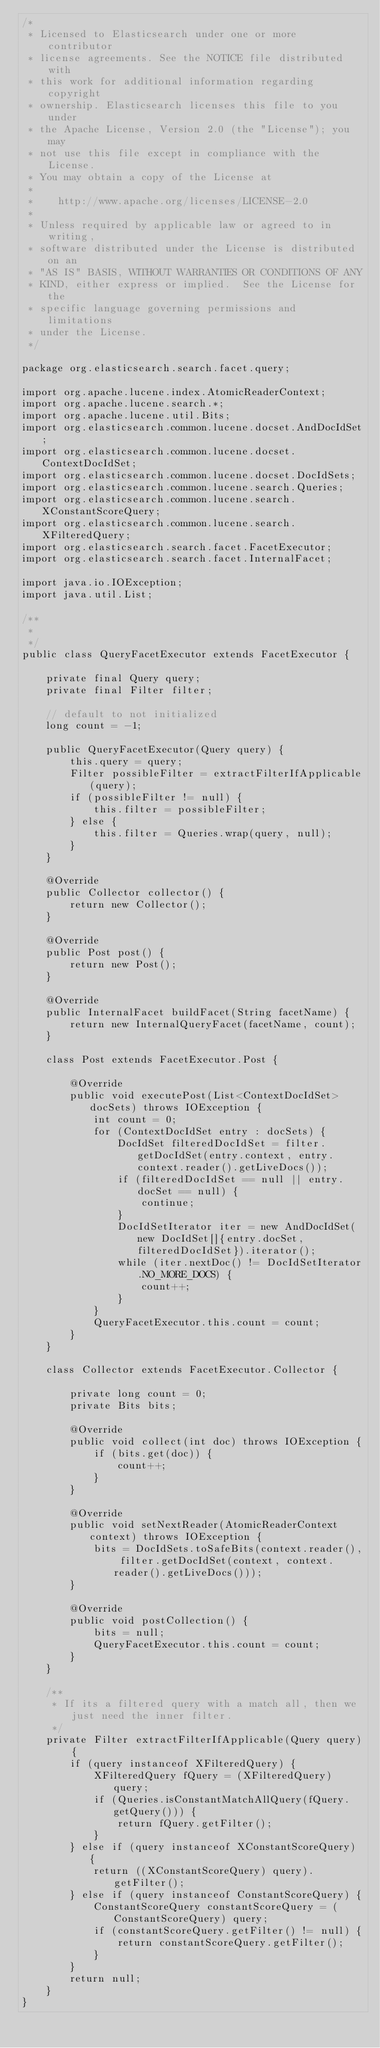Convert code to text. <code><loc_0><loc_0><loc_500><loc_500><_Java_>/*
 * Licensed to Elasticsearch under one or more contributor
 * license agreements. See the NOTICE file distributed with
 * this work for additional information regarding copyright
 * ownership. Elasticsearch licenses this file to you under
 * the Apache License, Version 2.0 (the "License"); you may
 * not use this file except in compliance with the License.
 * You may obtain a copy of the License at
 *
 *    http://www.apache.org/licenses/LICENSE-2.0
 *
 * Unless required by applicable law or agreed to in writing,
 * software distributed under the License is distributed on an
 * "AS IS" BASIS, WITHOUT WARRANTIES OR CONDITIONS OF ANY
 * KIND, either express or implied.  See the License for the
 * specific language governing permissions and limitations
 * under the License.
 */

package org.elasticsearch.search.facet.query;

import org.apache.lucene.index.AtomicReaderContext;
import org.apache.lucene.search.*;
import org.apache.lucene.util.Bits;
import org.elasticsearch.common.lucene.docset.AndDocIdSet;
import org.elasticsearch.common.lucene.docset.ContextDocIdSet;
import org.elasticsearch.common.lucene.docset.DocIdSets;
import org.elasticsearch.common.lucene.search.Queries;
import org.elasticsearch.common.lucene.search.XConstantScoreQuery;
import org.elasticsearch.common.lucene.search.XFilteredQuery;
import org.elasticsearch.search.facet.FacetExecutor;
import org.elasticsearch.search.facet.InternalFacet;

import java.io.IOException;
import java.util.List;

/**
 *
 */
public class QueryFacetExecutor extends FacetExecutor {

    private final Query query;
    private final Filter filter;

    // default to not initialized
    long count = -1;

    public QueryFacetExecutor(Query query) {
        this.query = query;
        Filter possibleFilter = extractFilterIfApplicable(query);
        if (possibleFilter != null) {
            this.filter = possibleFilter;
        } else {
            this.filter = Queries.wrap(query, null);
        }
    }

    @Override
    public Collector collector() {
        return new Collector();
    }

    @Override
    public Post post() {
        return new Post();
    }

    @Override
    public InternalFacet buildFacet(String facetName) {
        return new InternalQueryFacet(facetName, count);
    }

    class Post extends FacetExecutor.Post {

        @Override
        public void executePost(List<ContextDocIdSet> docSets) throws IOException {
            int count = 0;
            for (ContextDocIdSet entry : docSets) {
                DocIdSet filteredDocIdSet = filter.getDocIdSet(entry.context, entry.context.reader().getLiveDocs());
                if (filteredDocIdSet == null || entry.docSet == null) {
                    continue;
                }
                DocIdSetIterator iter = new AndDocIdSet(new DocIdSet[]{entry.docSet, filteredDocIdSet}).iterator();
                while (iter.nextDoc() != DocIdSetIterator.NO_MORE_DOCS) {
                    count++;
                }
            }
            QueryFacetExecutor.this.count = count;
        }
    }

    class Collector extends FacetExecutor.Collector {

        private long count = 0;
        private Bits bits;

        @Override
        public void collect(int doc) throws IOException {
            if (bits.get(doc)) {
                count++;
            }
        }

        @Override
        public void setNextReader(AtomicReaderContext context) throws IOException {
            bits = DocIdSets.toSafeBits(context.reader(), filter.getDocIdSet(context, context.reader().getLiveDocs()));
        }

        @Override
        public void postCollection() {
            bits = null;
            QueryFacetExecutor.this.count = count;
        }
    }

    /**
     * If its a filtered query with a match all, then we just need the inner filter.
     */
    private Filter extractFilterIfApplicable(Query query) {
        if (query instanceof XFilteredQuery) {
            XFilteredQuery fQuery = (XFilteredQuery) query;
            if (Queries.isConstantMatchAllQuery(fQuery.getQuery())) {
                return fQuery.getFilter();
            }
        } else if (query instanceof XConstantScoreQuery) {
            return ((XConstantScoreQuery) query).getFilter();
        } else if (query instanceof ConstantScoreQuery) {
            ConstantScoreQuery constantScoreQuery = (ConstantScoreQuery) query;
            if (constantScoreQuery.getFilter() != null) {
                return constantScoreQuery.getFilter();
            }
        }
        return null;
    }
}
</code> 